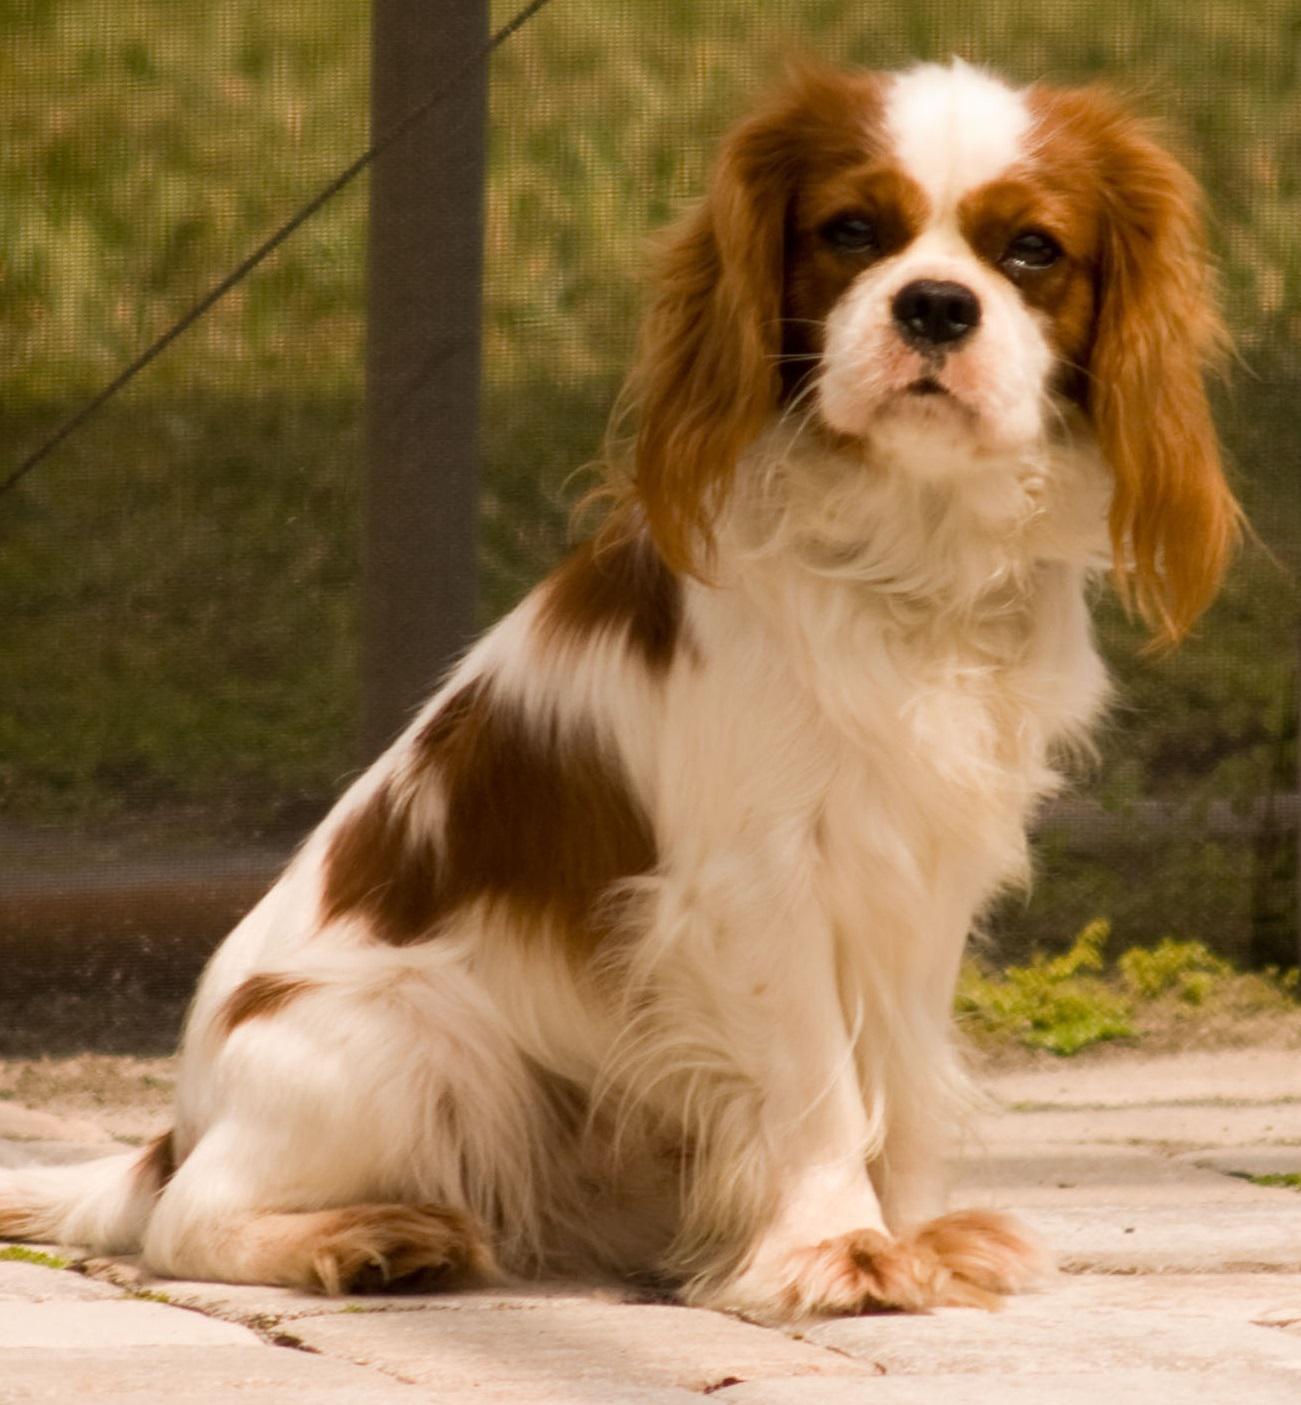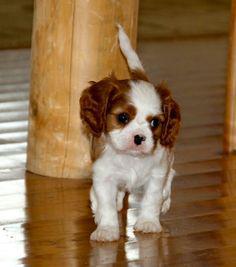The first image is the image on the left, the second image is the image on the right. Assess this claim about the two images: "An image contains at least two dogs.". Correct or not? Answer yes or no. No. 